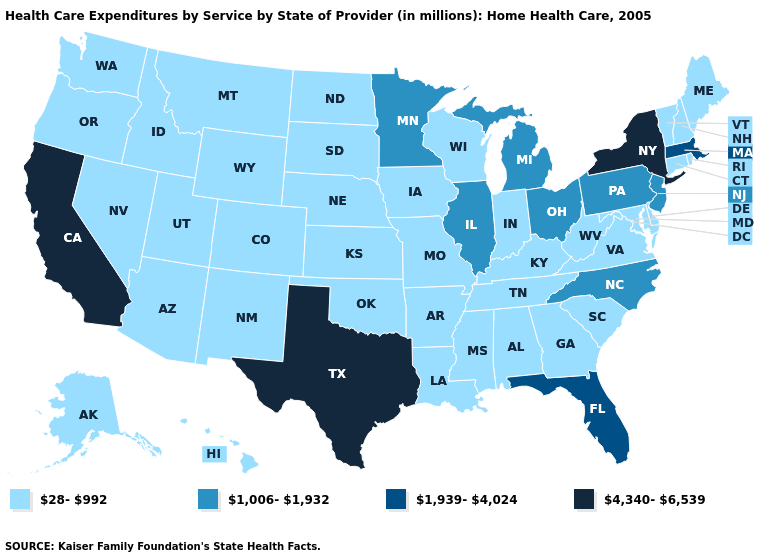What is the value of North Dakota?
Write a very short answer. 28-992. What is the highest value in the USA?
Write a very short answer. 4,340-6,539. Does the first symbol in the legend represent the smallest category?
Quick response, please. Yes. Among the states that border Rhode Island , which have the highest value?
Keep it brief. Massachusetts. Among the states that border Rhode Island , which have the lowest value?
Answer briefly. Connecticut. What is the highest value in states that border Ohio?
Keep it brief. 1,006-1,932. What is the lowest value in the MidWest?
Write a very short answer. 28-992. Name the states that have a value in the range 28-992?
Keep it brief. Alabama, Alaska, Arizona, Arkansas, Colorado, Connecticut, Delaware, Georgia, Hawaii, Idaho, Indiana, Iowa, Kansas, Kentucky, Louisiana, Maine, Maryland, Mississippi, Missouri, Montana, Nebraska, Nevada, New Hampshire, New Mexico, North Dakota, Oklahoma, Oregon, Rhode Island, South Carolina, South Dakota, Tennessee, Utah, Vermont, Virginia, Washington, West Virginia, Wisconsin, Wyoming. Which states have the highest value in the USA?
Give a very brief answer. California, New York, Texas. What is the value of Delaware?
Short answer required. 28-992. Among the states that border Maryland , does Pennsylvania have the highest value?
Give a very brief answer. Yes. How many symbols are there in the legend?
Answer briefly. 4. Which states have the lowest value in the USA?
Be succinct. Alabama, Alaska, Arizona, Arkansas, Colorado, Connecticut, Delaware, Georgia, Hawaii, Idaho, Indiana, Iowa, Kansas, Kentucky, Louisiana, Maine, Maryland, Mississippi, Missouri, Montana, Nebraska, Nevada, New Hampshire, New Mexico, North Dakota, Oklahoma, Oregon, Rhode Island, South Carolina, South Dakota, Tennessee, Utah, Vermont, Virginia, Washington, West Virginia, Wisconsin, Wyoming. Name the states that have a value in the range 1,006-1,932?
Write a very short answer. Illinois, Michigan, Minnesota, New Jersey, North Carolina, Ohio, Pennsylvania. What is the lowest value in the USA?
Concise answer only. 28-992. 